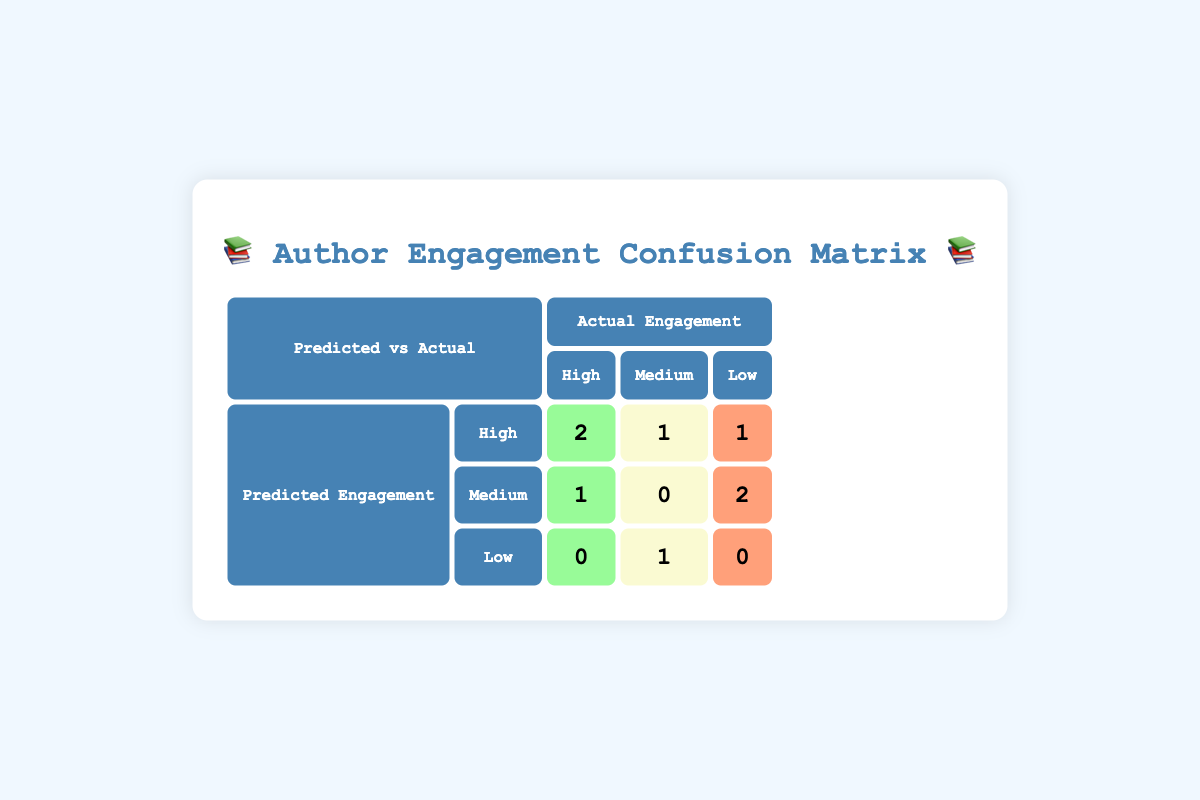What is the count of authors predicted to have high engagement that actually had high engagement? From the table, we look under the "High" column for "High" in the predicted engagement row. There are 2 authors: Colleen Hoover and J.K. Rowling.
Answer: 2 What is the total number of authors predicted to have medium engagement? The table shows 3 authors under the "Medium" row for predicted engagement: John Green, Agatha Christie, and Malcolm Gladwell. Thus, the total is 3.
Answer: 3 Did any authors predicted to have low engagement actually achieve high engagement? In the "Low" row for predicted engagement, there are no counts under the "High" column, indicating that zero authors predicted to have low engagement achieved high engagement.
Answer: No What is the difference in the number of authors predicted to have high engagement versus those predicted to have low engagement? There are 4 authors predicted to have high engagement (2 high-high + 1 high-medium + 1 high-low), and 3 authors predicted to have low engagement (0 high-high + 1 low-medium + 0 low-low). Therefore, the difference is 4 - 3 = 1.
Answer: 1 How many authors predicted to have high engagement did not actually achieve high engagement? The table shows 1 author predicted to have high engagement that achieved medium (Stephen King) and 1 author predicted high engagement that achieved low (George R.R. Martin), totaling 2 authors.
Answer: 2 What percentage of authors predicted to have medium engagement actually achieved high engagement? One author predicted medium engagement (John Green) achieved high engagement, and since there are 3 authors predicted medium, the percentage is (1/3) * 100 = 33.33%, which rounds to 33%.
Answer: 33% How many more authors had actual high engagement compared to those who were predicted to have low engagement? There were 3 authors with actual high engagement (2 from predicted high + 1 from predicted medium) and 0 from predicted low. Thus, the difference is 3 - 0 = 3.
Answer: 3 How many authors predicted low engagement had actual medium engagement? The "Low" row shows 1 author (Nora Roberts) that achieved medium engagement.
Answer: 1 What is the sum of authors predicted high engagement that achieved low and medium engagement? The table indicates 1 author achieved low (George R.R. Martin) and 1 author achieved medium (Stephen King), making the sum 1 + 1 = 2.
Answer: 2 